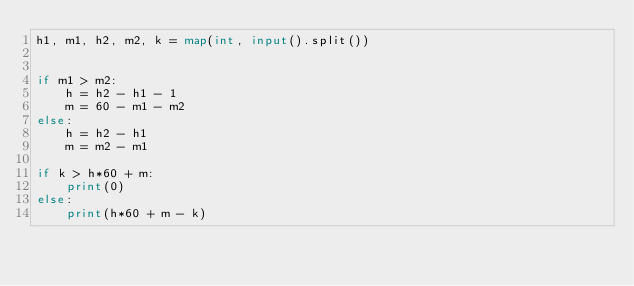<code> <loc_0><loc_0><loc_500><loc_500><_Python_>h1, m1, h2, m2, k = map(int, input().split())


if m1 > m2:
    h = h2 - h1 - 1
    m = 60 - m1 - m2
else:
    h = h2 - h1
    m = m2 - m1

if k > h*60 + m:
    print(0)
else:
    print(h*60 + m - k)
</code> 